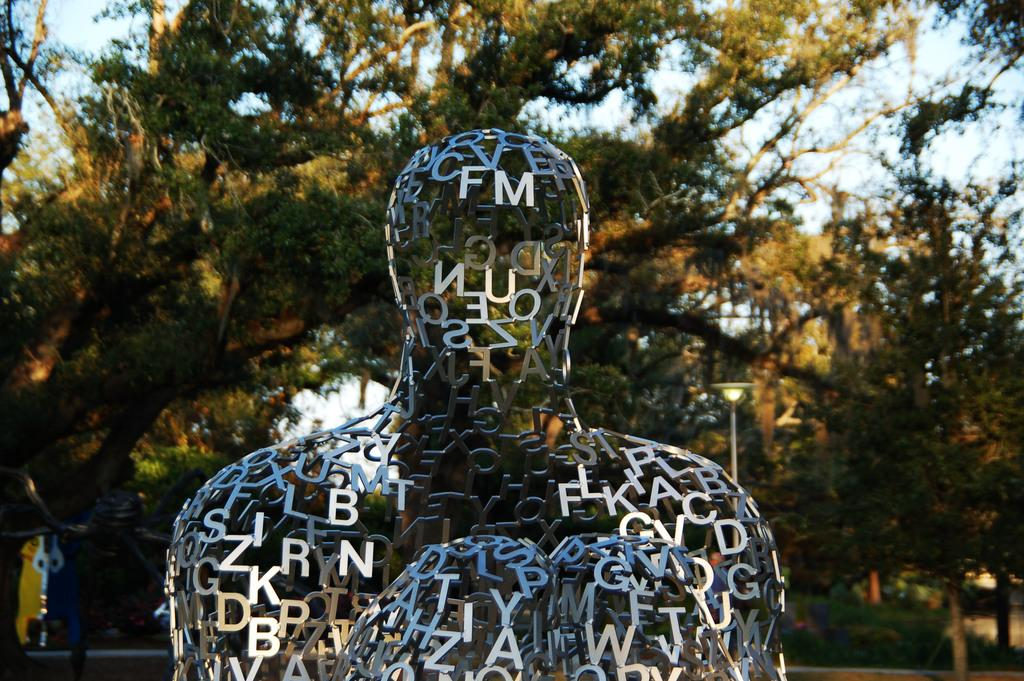What is the main subject in the center of the image? There is a statue in the center of the image. What can be seen in the background of the image? There are trees and the sky visible in the background of the image. What type of vein can be seen in the image? There is no vein present in the image. How many bulbs are visible in the image? There are no bulbs present in the image. 